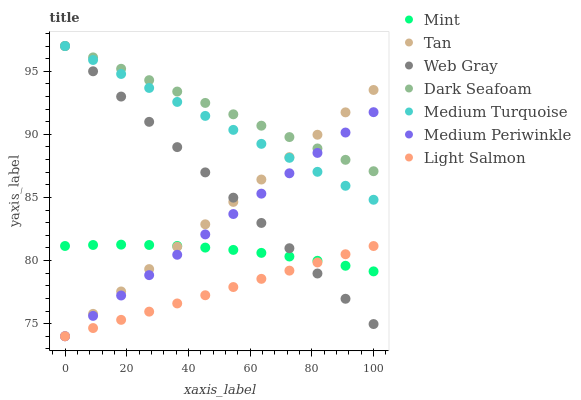Does Light Salmon have the minimum area under the curve?
Answer yes or no. Yes. Does Dark Seafoam have the maximum area under the curve?
Answer yes or no. Yes. Does Web Gray have the minimum area under the curve?
Answer yes or no. No. Does Web Gray have the maximum area under the curve?
Answer yes or no. No. Is Medium Periwinkle the smoothest?
Answer yes or no. Yes. Is Mint the roughest?
Answer yes or no. Yes. Is Web Gray the smoothest?
Answer yes or no. No. Is Web Gray the roughest?
Answer yes or no. No. Does Light Salmon have the lowest value?
Answer yes or no. Yes. Does Web Gray have the lowest value?
Answer yes or no. No. Does Medium Turquoise have the highest value?
Answer yes or no. Yes. Does Medium Periwinkle have the highest value?
Answer yes or no. No. Is Light Salmon less than Dark Seafoam?
Answer yes or no. Yes. Is Medium Turquoise greater than Light Salmon?
Answer yes or no. Yes. Does Medium Periwinkle intersect Dark Seafoam?
Answer yes or no. Yes. Is Medium Periwinkle less than Dark Seafoam?
Answer yes or no. No. Is Medium Periwinkle greater than Dark Seafoam?
Answer yes or no. No. Does Light Salmon intersect Dark Seafoam?
Answer yes or no. No. 